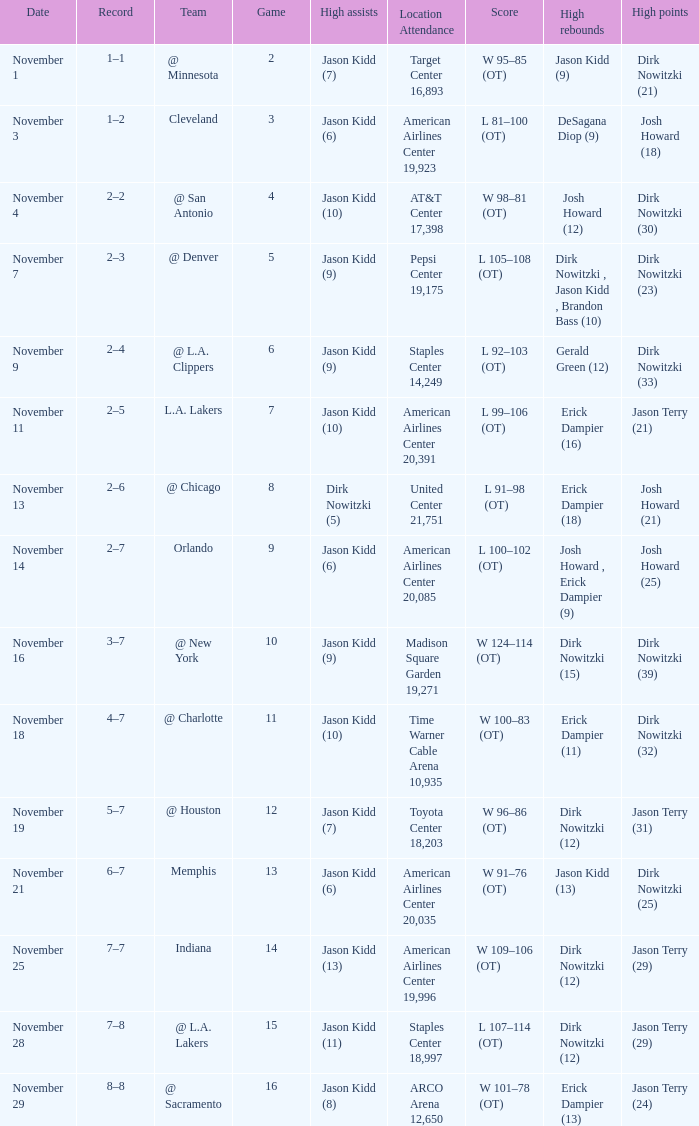Parse the full table. {'header': ['Date', 'Record', 'Team', 'Game', 'High assists', 'Location Attendance', 'Score', 'High rebounds', 'High points'], 'rows': [['November 1', '1–1', '@ Minnesota', '2', 'Jason Kidd (7)', 'Target Center 16,893', 'W 95–85 (OT)', 'Jason Kidd (9)', 'Dirk Nowitzki (21)'], ['November 3', '1–2', 'Cleveland', '3', 'Jason Kidd (6)', 'American Airlines Center 19,923', 'L 81–100 (OT)', 'DeSagana Diop (9)', 'Josh Howard (18)'], ['November 4', '2–2', '@ San Antonio', '4', 'Jason Kidd (10)', 'AT&T Center 17,398', 'W 98–81 (OT)', 'Josh Howard (12)', 'Dirk Nowitzki (30)'], ['November 7', '2–3', '@ Denver', '5', 'Jason Kidd (9)', 'Pepsi Center 19,175', 'L 105–108 (OT)', 'Dirk Nowitzki , Jason Kidd , Brandon Bass (10)', 'Dirk Nowitzki (23)'], ['November 9', '2–4', '@ L.A. Clippers', '6', 'Jason Kidd (9)', 'Staples Center 14,249', 'L 92–103 (OT)', 'Gerald Green (12)', 'Dirk Nowitzki (33)'], ['November 11', '2–5', 'L.A. Lakers', '7', 'Jason Kidd (10)', 'American Airlines Center 20,391', 'L 99–106 (OT)', 'Erick Dampier (16)', 'Jason Terry (21)'], ['November 13', '2–6', '@ Chicago', '8', 'Dirk Nowitzki (5)', 'United Center 21,751', 'L 91–98 (OT)', 'Erick Dampier (18)', 'Josh Howard (21)'], ['November 14', '2–7', 'Orlando', '9', 'Jason Kidd (6)', 'American Airlines Center 20,085', 'L 100–102 (OT)', 'Josh Howard , Erick Dampier (9)', 'Josh Howard (25)'], ['November 16', '3–7', '@ New York', '10', 'Jason Kidd (9)', 'Madison Square Garden 19,271', 'W 124–114 (OT)', 'Dirk Nowitzki (15)', 'Dirk Nowitzki (39)'], ['November 18', '4–7', '@ Charlotte', '11', 'Jason Kidd (10)', 'Time Warner Cable Arena 10,935', 'W 100–83 (OT)', 'Erick Dampier (11)', 'Dirk Nowitzki (32)'], ['November 19', '5–7', '@ Houston', '12', 'Jason Kidd (7)', 'Toyota Center 18,203', 'W 96–86 (OT)', 'Dirk Nowitzki (12)', 'Jason Terry (31)'], ['November 21', '6–7', 'Memphis', '13', 'Jason Kidd (6)', 'American Airlines Center 20,035', 'W 91–76 (OT)', 'Jason Kidd (13)', 'Dirk Nowitzki (25)'], ['November 25', '7–7', 'Indiana', '14', 'Jason Kidd (13)', 'American Airlines Center 19,996', 'W 109–106 (OT)', 'Dirk Nowitzki (12)', 'Jason Terry (29)'], ['November 28', '7–8', '@ L.A. Lakers', '15', 'Jason Kidd (11)', 'Staples Center 18,997', 'L 107–114 (OT)', 'Dirk Nowitzki (12)', 'Jason Terry (29)'], ['November 29', '8–8', '@ Sacramento', '16', 'Jason Kidd (8)', 'ARCO Arena 12,650', 'W 101–78 (OT)', 'Erick Dampier (13)', 'Jason Terry (24)']]} What is the lowest Game, when Date is "November 1"? 2.0. 